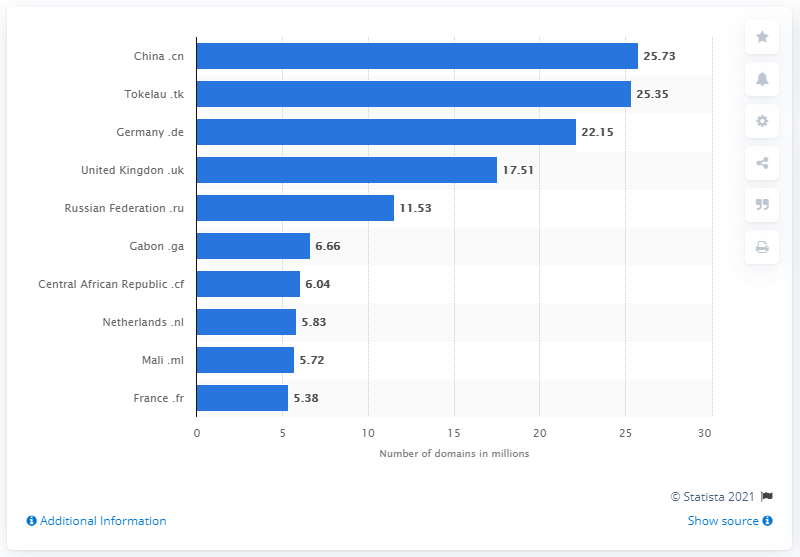Outline some significant characteristics in this image. As of April 2021, a total of 25.73 domains were registered in China. Tokelau's .tk domain had 25.35 registered domains. 